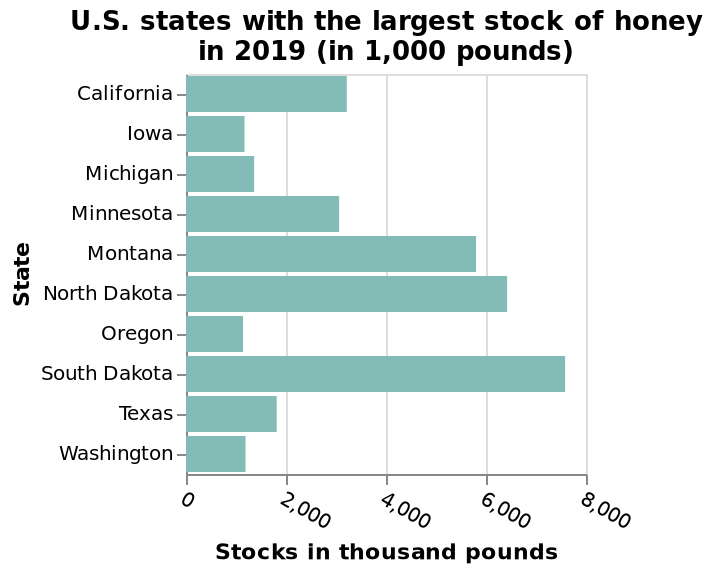<image>
What is the minimum value on the x-axis of the bar graph?  0 please summary the statistics and relations of the chart South dakota has the highest amount of honey with nearly 8000. Iowa has the lowest stock with about 1000. What is the maximum value on the x-axis of the bar diagram? 8,000 